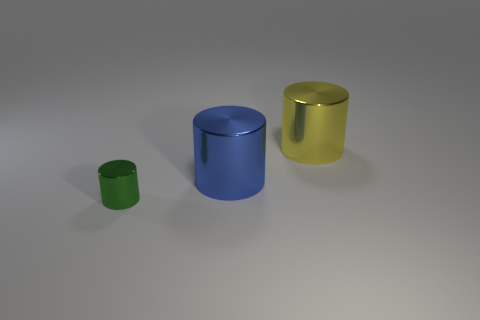Add 2 green shiny cylinders. How many objects exist? 5 Subtract 0 red cylinders. How many objects are left? 3 Subtract all big metal objects. Subtract all large blue cylinders. How many objects are left? 0 Add 1 blue shiny things. How many blue shiny things are left? 2 Add 1 large yellow metal cylinders. How many large yellow metal cylinders exist? 2 